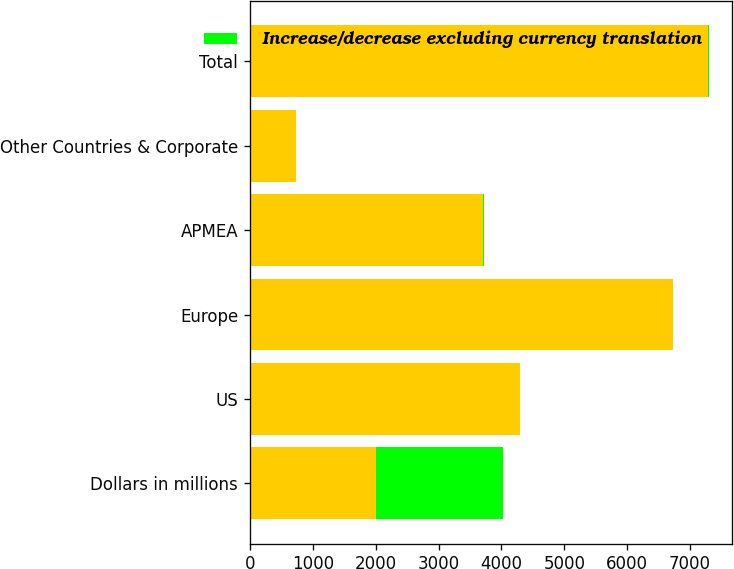<chart> <loc_0><loc_0><loc_500><loc_500><stacked_bar_chart><ecel><fcel>Dollars in millions<fcel>US<fcel>Europe<fcel>APMEA<fcel>Other Countries & Corporate<fcel>Total<nl><fcel>nan<fcel>2009<fcel>4295<fcel>6721<fcel>3714<fcel>729<fcel>7286<nl><fcel>Increase/decrease excluding currency translation<fcel>2009<fcel>7<fcel>3<fcel>5<fcel>7<fcel>8<nl></chart> 